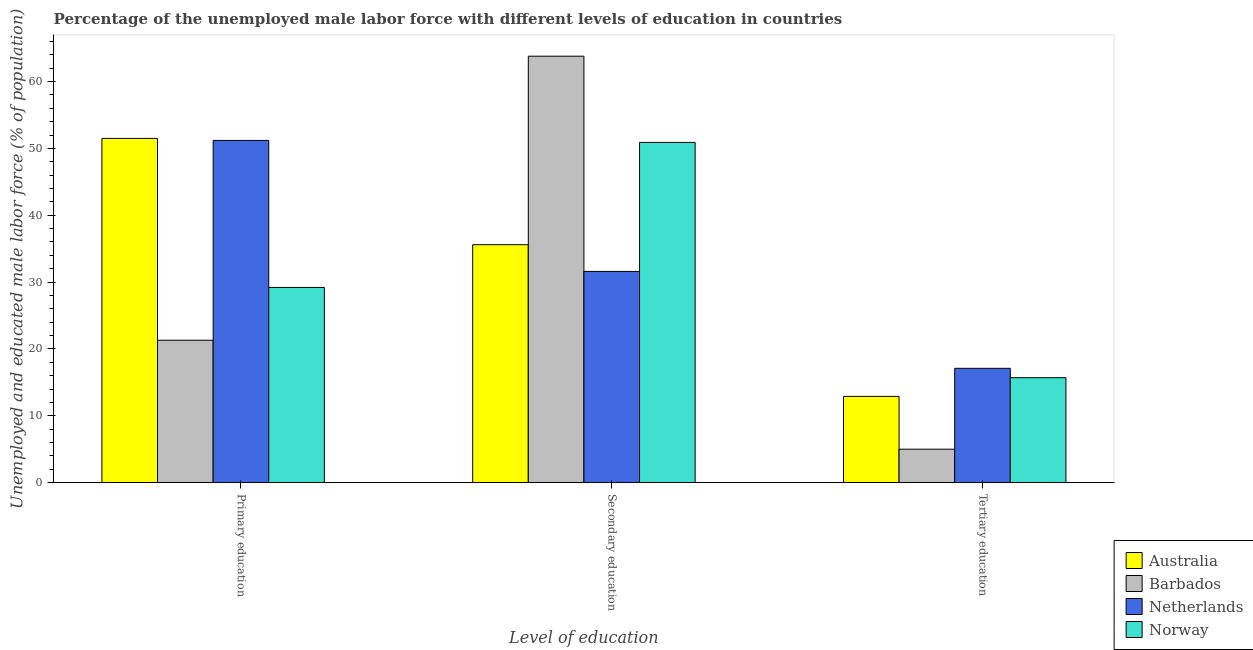How many groups of bars are there?
Provide a succinct answer. 3. Are the number of bars per tick equal to the number of legend labels?
Keep it short and to the point. Yes. Are the number of bars on each tick of the X-axis equal?
Make the answer very short. Yes. What is the label of the 2nd group of bars from the left?
Offer a terse response. Secondary education. What is the percentage of male labor force who received primary education in Barbados?
Offer a terse response. 21.3. Across all countries, what is the maximum percentage of male labor force who received secondary education?
Give a very brief answer. 63.8. Across all countries, what is the minimum percentage of male labor force who received primary education?
Your answer should be very brief. 21.3. What is the total percentage of male labor force who received tertiary education in the graph?
Make the answer very short. 50.7. What is the difference between the percentage of male labor force who received tertiary education in Netherlands and that in Barbados?
Keep it short and to the point. 12.1. What is the difference between the percentage of male labor force who received primary education in Norway and the percentage of male labor force who received secondary education in Australia?
Make the answer very short. -6.4. What is the average percentage of male labor force who received primary education per country?
Give a very brief answer. 38.3. What is the difference between the percentage of male labor force who received primary education and percentage of male labor force who received tertiary education in Australia?
Offer a terse response. 38.6. In how many countries, is the percentage of male labor force who received tertiary education greater than 30 %?
Keep it short and to the point. 0. What is the ratio of the percentage of male labor force who received primary education in Netherlands to that in Barbados?
Offer a very short reply. 2.4. Is the percentage of male labor force who received tertiary education in Barbados less than that in Norway?
Give a very brief answer. Yes. Is the difference between the percentage of male labor force who received tertiary education in Norway and Australia greater than the difference between the percentage of male labor force who received secondary education in Norway and Australia?
Offer a very short reply. No. What is the difference between the highest and the second highest percentage of male labor force who received tertiary education?
Keep it short and to the point. 1.4. What is the difference between the highest and the lowest percentage of male labor force who received tertiary education?
Make the answer very short. 12.1. What does the 3rd bar from the right in Primary education represents?
Keep it short and to the point. Barbados. Is it the case that in every country, the sum of the percentage of male labor force who received primary education and percentage of male labor force who received secondary education is greater than the percentage of male labor force who received tertiary education?
Your response must be concise. Yes. How many bars are there?
Your answer should be very brief. 12. Are all the bars in the graph horizontal?
Give a very brief answer. No. How many countries are there in the graph?
Your answer should be compact. 4. Does the graph contain any zero values?
Offer a very short reply. No. Where does the legend appear in the graph?
Your answer should be very brief. Bottom right. How are the legend labels stacked?
Your answer should be compact. Vertical. What is the title of the graph?
Make the answer very short. Percentage of the unemployed male labor force with different levels of education in countries. What is the label or title of the X-axis?
Provide a short and direct response. Level of education. What is the label or title of the Y-axis?
Offer a terse response. Unemployed and educated male labor force (% of population). What is the Unemployed and educated male labor force (% of population) in Australia in Primary education?
Keep it short and to the point. 51.5. What is the Unemployed and educated male labor force (% of population) in Barbados in Primary education?
Ensure brevity in your answer.  21.3. What is the Unemployed and educated male labor force (% of population) of Netherlands in Primary education?
Make the answer very short. 51.2. What is the Unemployed and educated male labor force (% of population) in Norway in Primary education?
Make the answer very short. 29.2. What is the Unemployed and educated male labor force (% of population) of Australia in Secondary education?
Provide a succinct answer. 35.6. What is the Unemployed and educated male labor force (% of population) in Barbados in Secondary education?
Your answer should be compact. 63.8. What is the Unemployed and educated male labor force (% of population) of Netherlands in Secondary education?
Offer a terse response. 31.6. What is the Unemployed and educated male labor force (% of population) in Norway in Secondary education?
Give a very brief answer. 50.9. What is the Unemployed and educated male labor force (% of population) in Australia in Tertiary education?
Ensure brevity in your answer.  12.9. What is the Unemployed and educated male labor force (% of population) in Barbados in Tertiary education?
Your answer should be compact. 5. What is the Unemployed and educated male labor force (% of population) in Netherlands in Tertiary education?
Offer a terse response. 17.1. What is the Unemployed and educated male labor force (% of population) in Norway in Tertiary education?
Ensure brevity in your answer.  15.7. Across all Level of education, what is the maximum Unemployed and educated male labor force (% of population) of Australia?
Provide a succinct answer. 51.5. Across all Level of education, what is the maximum Unemployed and educated male labor force (% of population) of Barbados?
Provide a short and direct response. 63.8. Across all Level of education, what is the maximum Unemployed and educated male labor force (% of population) of Netherlands?
Give a very brief answer. 51.2. Across all Level of education, what is the maximum Unemployed and educated male labor force (% of population) of Norway?
Your answer should be very brief. 50.9. Across all Level of education, what is the minimum Unemployed and educated male labor force (% of population) of Australia?
Keep it short and to the point. 12.9. Across all Level of education, what is the minimum Unemployed and educated male labor force (% of population) in Barbados?
Provide a short and direct response. 5. Across all Level of education, what is the minimum Unemployed and educated male labor force (% of population) in Netherlands?
Offer a terse response. 17.1. Across all Level of education, what is the minimum Unemployed and educated male labor force (% of population) of Norway?
Your answer should be very brief. 15.7. What is the total Unemployed and educated male labor force (% of population) of Barbados in the graph?
Your response must be concise. 90.1. What is the total Unemployed and educated male labor force (% of population) of Netherlands in the graph?
Ensure brevity in your answer.  99.9. What is the total Unemployed and educated male labor force (% of population) of Norway in the graph?
Your answer should be very brief. 95.8. What is the difference between the Unemployed and educated male labor force (% of population) of Barbados in Primary education and that in Secondary education?
Give a very brief answer. -42.5. What is the difference between the Unemployed and educated male labor force (% of population) of Netherlands in Primary education and that in Secondary education?
Provide a succinct answer. 19.6. What is the difference between the Unemployed and educated male labor force (% of population) of Norway in Primary education and that in Secondary education?
Your answer should be very brief. -21.7. What is the difference between the Unemployed and educated male labor force (% of population) in Australia in Primary education and that in Tertiary education?
Your response must be concise. 38.6. What is the difference between the Unemployed and educated male labor force (% of population) in Barbados in Primary education and that in Tertiary education?
Make the answer very short. 16.3. What is the difference between the Unemployed and educated male labor force (% of population) in Netherlands in Primary education and that in Tertiary education?
Make the answer very short. 34.1. What is the difference between the Unemployed and educated male labor force (% of population) of Australia in Secondary education and that in Tertiary education?
Your answer should be compact. 22.7. What is the difference between the Unemployed and educated male labor force (% of population) in Barbados in Secondary education and that in Tertiary education?
Provide a short and direct response. 58.8. What is the difference between the Unemployed and educated male labor force (% of population) in Netherlands in Secondary education and that in Tertiary education?
Offer a terse response. 14.5. What is the difference between the Unemployed and educated male labor force (% of population) of Norway in Secondary education and that in Tertiary education?
Your answer should be very brief. 35.2. What is the difference between the Unemployed and educated male labor force (% of population) in Australia in Primary education and the Unemployed and educated male labor force (% of population) in Barbados in Secondary education?
Offer a terse response. -12.3. What is the difference between the Unemployed and educated male labor force (% of population) in Australia in Primary education and the Unemployed and educated male labor force (% of population) in Netherlands in Secondary education?
Keep it short and to the point. 19.9. What is the difference between the Unemployed and educated male labor force (% of population) of Australia in Primary education and the Unemployed and educated male labor force (% of population) of Norway in Secondary education?
Ensure brevity in your answer.  0.6. What is the difference between the Unemployed and educated male labor force (% of population) of Barbados in Primary education and the Unemployed and educated male labor force (% of population) of Netherlands in Secondary education?
Your answer should be compact. -10.3. What is the difference between the Unemployed and educated male labor force (% of population) in Barbados in Primary education and the Unemployed and educated male labor force (% of population) in Norway in Secondary education?
Give a very brief answer. -29.6. What is the difference between the Unemployed and educated male labor force (% of population) in Australia in Primary education and the Unemployed and educated male labor force (% of population) in Barbados in Tertiary education?
Provide a succinct answer. 46.5. What is the difference between the Unemployed and educated male labor force (% of population) in Australia in Primary education and the Unemployed and educated male labor force (% of population) in Netherlands in Tertiary education?
Keep it short and to the point. 34.4. What is the difference between the Unemployed and educated male labor force (% of population) of Australia in Primary education and the Unemployed and educated male labor force (% of population) of Norway in Tertiary education?
Your answer should be compact. 35.8. What is the difference between the Unemployed and educated male labor force (% of population) of Barbados in Primary education and the Unemployed and educated male labor force (% of population) of Netherlands in Tertiary education?
Give a very brief answer. 4.2. What is the difference between the Unemployed and educated male labor force (% of population) of Barbados in Primary education and the Unemployed and educated male labor force (% of population) of Norway in Tertiary education?
Provide a short and direct response. 5.6. What is the difference between the Unemployed and educated male labor force (% of population) of Netherlands in Primary education and the Unemployed and educated male labor force (% of population) of Norway in Tertiary education?
Provide a short and direct response. 35.5. What is the difference between the Unemployed and educated male labor force (% of population) of Australia in Secondary education and the Unemployed and educated male labor force (% of population) of Barbados in Tertiary education?
Provide a succinct answer. 30.6. What is the difference between the Unemployed and educated male labor force (% of population) of Australia in Secondary education and the Unemployed and educated male labor force (% of population) of Netherlands in Tertiary education?
Provide a succinct answer. 18.5. What is the difference between the Unemployed and educated male labor force (% of population) of Australia in Secondary education and the Unemployed and educated male labor force (% of population) of Norway in Tertiary education?
Offer a terse response. 19.9. What is the difference between the Unemployed and educated male labor force (% of population) of Barbados in Secondary education and the Unemployed and educated male labor force (% of population) of Netherlands in Tertiary education?
Ensure brevity in your answer.  46.7. What is the difference between the Unemployed and educated male labor force (% of population) in Barbados in Secondary education and the Unemployed and educated male labor force (% of population) in Norway in Tertiary education?
Keep it short and to the point. 48.1. What is the average Unemployed and educated male labor force (% of population) of Australia per Level of education?
Make the answer very short. 33.33. What is the average Unemployed and educated male labor force (% of population) of Barbados per Level of education?
Ensure brevity in your answer.  30.03. What is the average Unemployed and educated male labor force (% of population) in Netherlands per Level of education?
Give a very brief answer. 33.3. What is the average Unemployed and educated male labor force (% of population) in Norway per Level of education?
Offer a very short reply. 31.93. What is the difference between the Unemployed and educated male labor force (% of population) of Australia and Unemployed and educated male labor force (% of population) of Barbados in Primary education?
Offer a very short reply. 30.2. What is the difference between the Unemployed and educated male labor force (% of population) of Australia and Unemployed and educated male labor force (% of population) of Norway in Primary education?
Your answer should be compact. 22.3. What is the difference between the Unemployed and educated male labor force (% of population) in Barbados and Unemployed and educated male labor force (% of population) in Netherlands in Primary education?
Give a very brief answer. -29.9. What is the difference between the Unemployed and educated male labor force (% of population) in Barbados and Unemployed and educated male labor force (% of population) in Norway in Primary education?
Provide a succinct answer. -7.9. What is the difference between the Unemployed and educated male labor force (% of population) of Australia and Unemployed and educated male labor force (% of population) of Barbados in Secondary education?
Provide a succinct answer. -28.2. What is the difference between the Unemployed and educated male labor force (% of population) in Australia and Unemployed and educated male labor force (% of population) in Netherlands in Secondary education?
Offer a terse response. 4. What is the difference between the Unemployed and educated male labor force (% of population) of Australia and Unemployed and educated male labor force (% of population) of Norway in Secondary education?
Ensure brevity in your answer.  -15.3. What is the difference between the Unemployed and educated male labor force (% of population) of Barbados and Unemployed and educated male labor force (% of population) of Netherlands in Secondary education?
Offer a very short reply. 32.2. What is the difference between the Unemployed and educated male labor force (% of population) in Netherlands and Unemployed and educated male labor force (% of population) in Norway in Secondary education?
Your response must be concise. -19.3. What is the difference between the Unemployed and educated male labor force (% of population) of Barbados and Unemployed and educated male labor force (% of population) of Netherlands in Tertiary education?
Provide a succinct answer. -12.1. What is the difference between the Unemployed and educated male labor force (% of population) of Barbados and Unemployed and educated male labor force (% of population) of Norway in Tertiary education?
Provide a short and direct response. -10.7. What is the ratio of the Unemployed and educated male labor force (% of population) in Australia in Primary education to that in Secondary education?
Ensure brevity in your answer.  1.45. What is the ratio of the Unemployed and educated male labor force (% of population) in Barbados in Primary education to that in Secondary education?
Give a very brief answer. 0.33. What is the ratio of the Unemployed and educated male labor force (% of population) in Netherlands in Primary education to that in Secondary education?
Ensure brevity in your answer.  1.62. What is the ratio of the Unemployed and educated male labor force (% of population) of Norway in Primary education to that in Secondary education?
Provide a succinct answer. 0.57. What is the ratio of the Unemployed and educated male labor force (% of population) in Australia in Primary education to that in Tertiary education?
Your response must be concise. 3.99. What is the ratio of the Unemployed and educated male labor force (% of population) of Barbados in Primary education to that in Tertiary education?
Provide a succinct answer. 4.26. What is the ratio of the Unemployed and educated male labor force (% of population) of Netherlands in Primary education to that in Tertiary education?
Your response must be concise. 2.99. What is the ratio of the Unemployed and educated male labor force (% of population) in Norway in Primary education to that in Tertiary education?
Give a very brief answer. 1.86. What is the ratio of the Unemployed and educated male labor force (% of population) in Australia in Secondary education to that in Tertiary education?
Offer a very short reply. 2.76. What is the ratio of the Unemployed and educated male labor force (% of population) of Barbados in Secondary education to that in Tertiary education?
Make the answer very short. 12.76. What is the ratio of the Unemployed and educated male labor force (% of population) in Netherlands in Secondary education to that in Tertiary education?
Your answer should be compact. 1.85. What is the ratio of the Unemployed and educated male labor force (% of population) of Norway in Secondary education to that in Tertiary education?
Your response must be concise. 3.24. What is the difference between the highest and the second highest Unemployed and educated male labor force (% of population) in Barbados?
Offer a very short reply. 42.5. What is the difference between the highest and the second highest Unemployed and educated male labor force (% of population) of Netherlands?
Give a very brief answer. 19.6. What is the difference between the highest and the second highest Unemployed and educated male labor force (% of population) in Norway?
Keep it short and to the point. 21.7. What is the difference between the highest and the lowest Unemployed and educated male labor force (% of population) of Australia?
Ensure brevity in your answer.  38.6. What is the difference between the highest and the lowest Unemployed and educated male labor force (% of population) in Barbados?
Your answer should be very brief. 58.8. What is the difference between the highest and the lowest Unemployed and educated male labor force (% of population) in Netherlands?
Give a very brief answer. 34.1. What is the difference between the highest and the lowest Unemployed and educated male labor force (% of population) in Norway?
Ensure brevity in your answer.  35.2. 